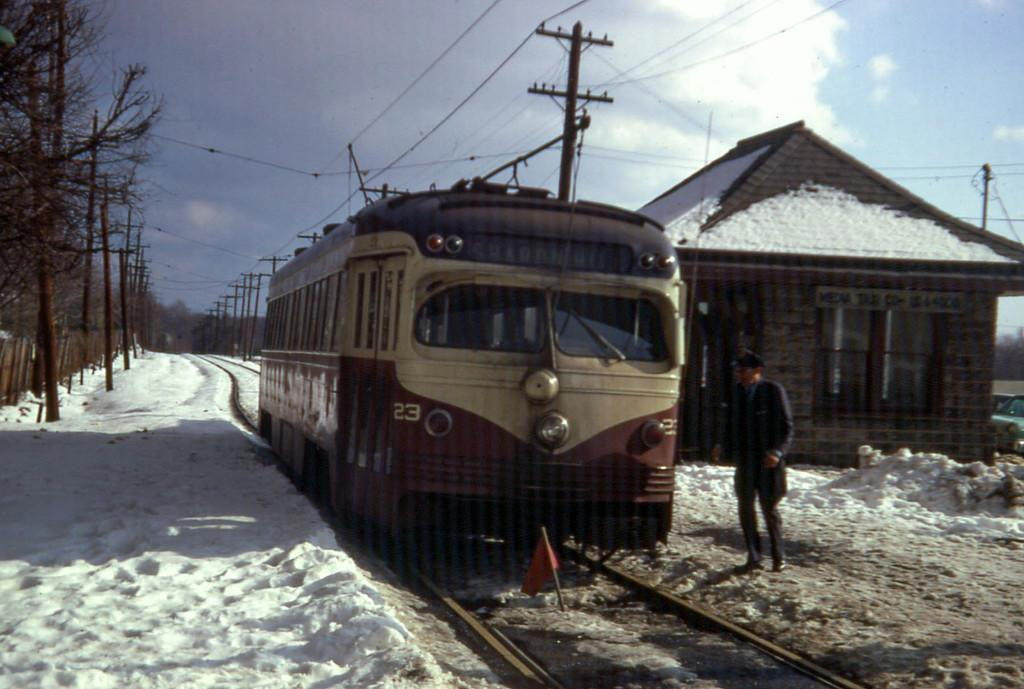What is the main subject of the image? The main subject of the image is a train. What can be seen in the image besides the train? There are rail tracks, a flag with a pole, snow on the ground, a house, poles, wires, trees, the sky, and clouds in the image. What is the weather like in the image? The ground has snow in the image, and there are clouds in the sky, suggesting a cold and possibly overcast day. What is the train's environment like in the image? The train is surrounded by snow, trees, and houses. What type of account does the actor have in the image? There is no actor or account present in the image. 